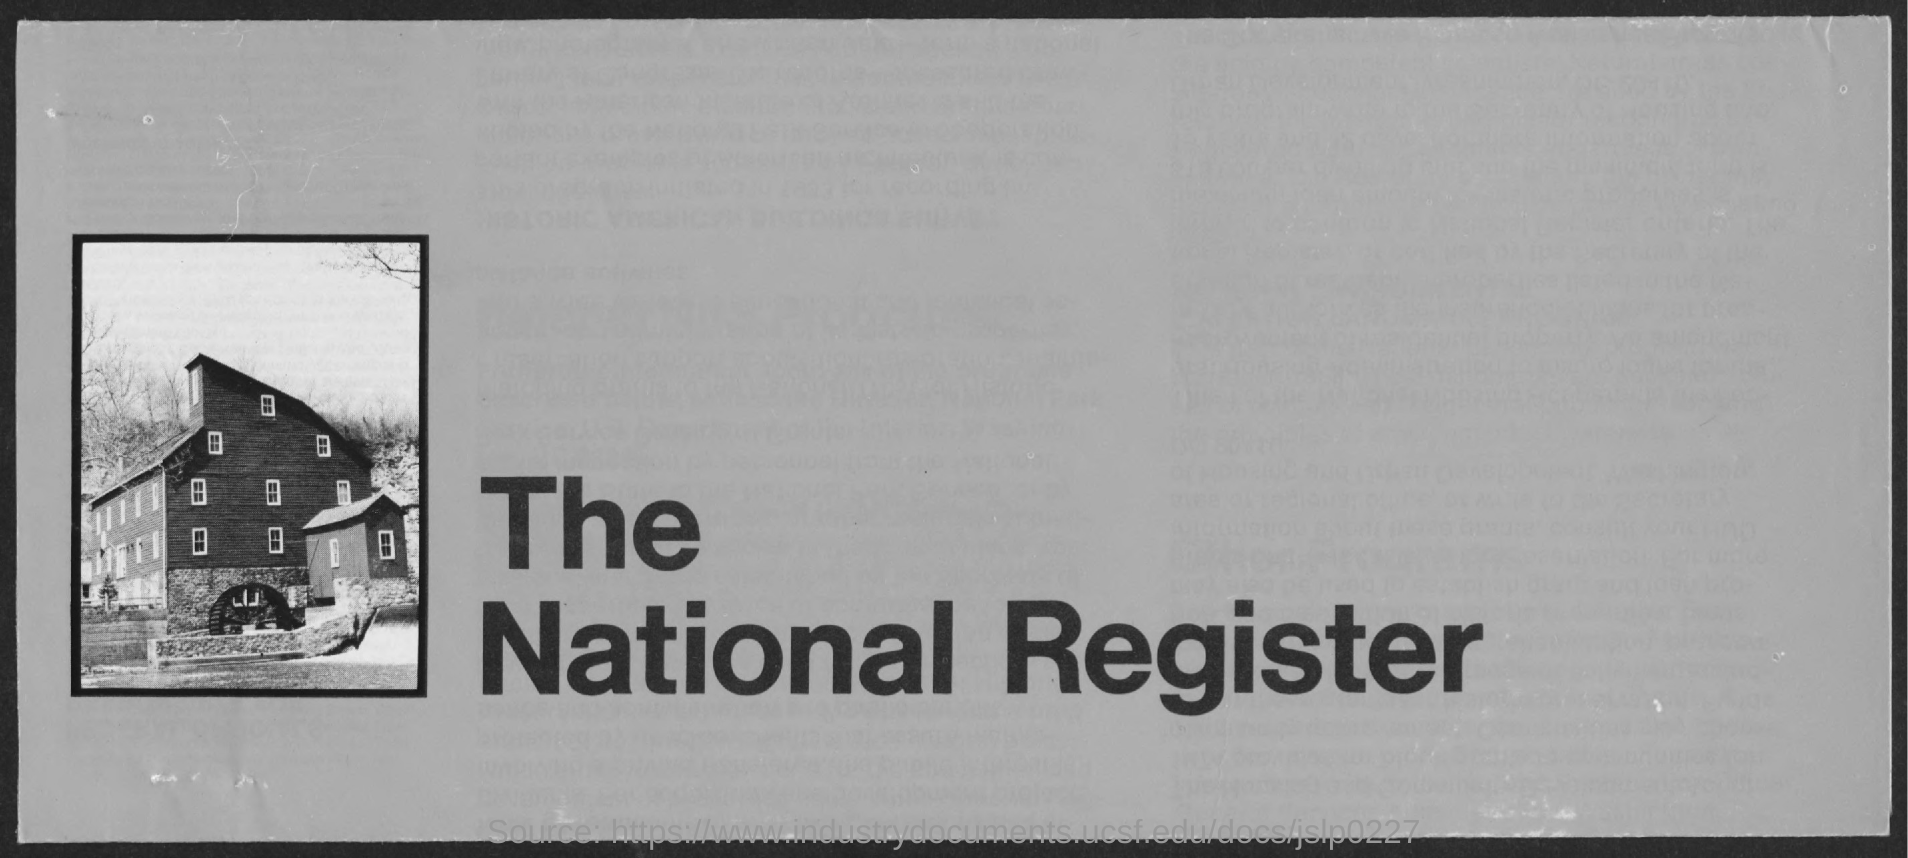Mention a couple of crucial points in this snapshot. The title of the document is 'What is the title of the document?' and it is registered under the national register. 